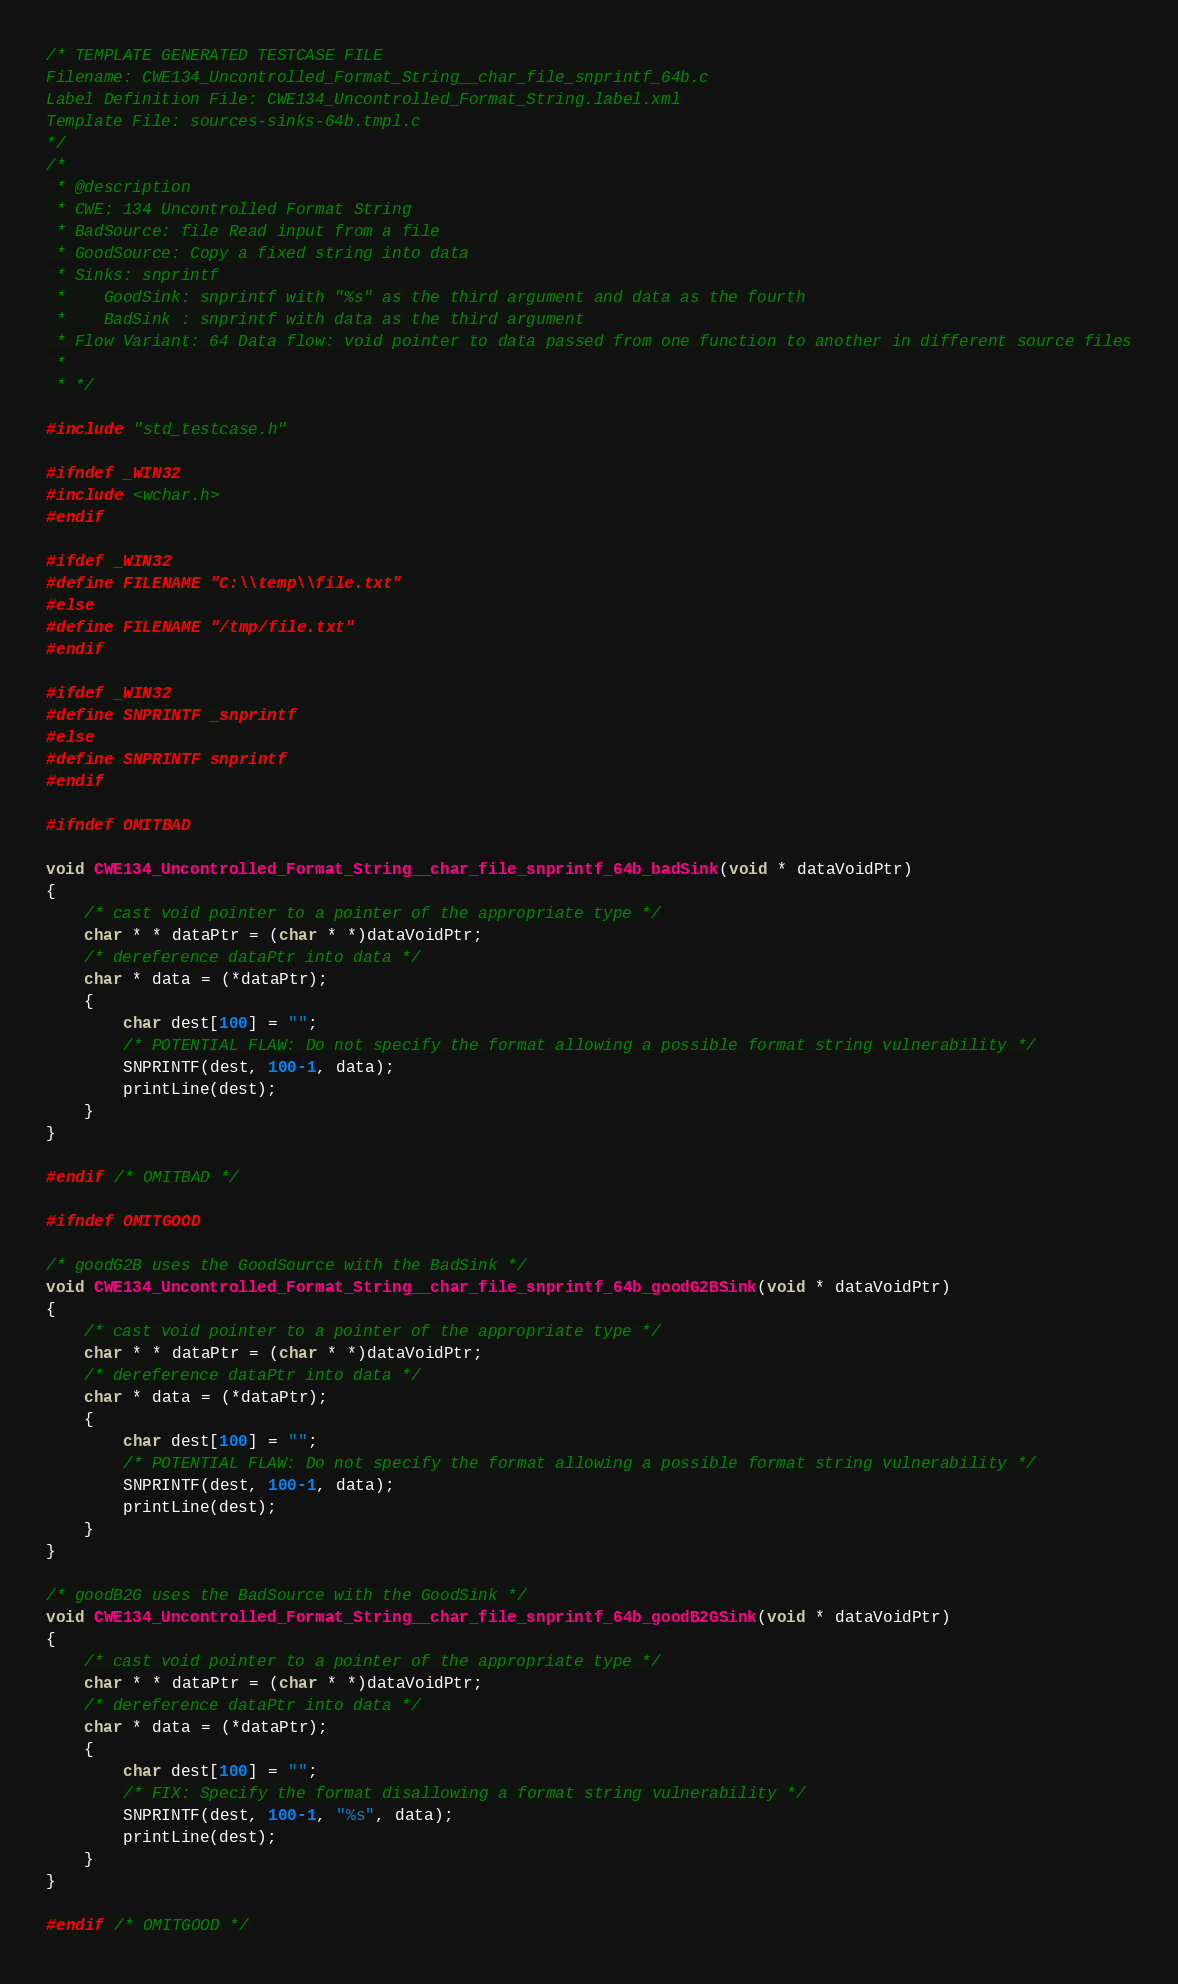<code> <loc_0><loc_0><loc_500><loc_500><_C_>/* TEMPLATE GENERATED TESTCASE FILE
Filename: CWE134_Uncontrolled_Format_String__char_file_snprintf_64b.c
Label Definition File: CWE134_Uncontrolled_Format_String.label.xml
Template File: sources-sinks-64b.tmpl.c
*/
/*
 * @description
 * CWE: 134 Uncontrolled Format String
 * BadSource: file Read input from a file
 * GoodSource: Copy a fixed string into data
 * Sinks: snprintf
 *    GoodSink: snprintf with "%s" as the third argument and data as the fourth
 *    BadSink : snprintf with data as the third argument
 * Flow Variant: 64 Data flow: void pointer to data passed from one function to another in different source files
 *
 * */

#include "std_testcase.h"

#ifndef _WIN32
#include <wchar.h>
#endif

#ifdef _WIN32
#define FILENAME "C:\\temp\\file.txt"
#else
#define FILENAME "/tmp/file.txt"
#endif

#ifdef _WIN32
#define SNPRINTF _snprintf
#else
#define SNPRINTF snprintf
#endif

#ifndef OMITBAD

void CWE134_Uncontrolled_Format_String__char_file_snprintf_64b_badSink(void * dataVoidPtr)
{
    /* cast void pointer to a pointer of the appropriate type */
    char * * dataPtr = (char * *)dataVoidPtr;
    /* dereference dataPtr into data */
    char * data = (*dataPtr);
    {
        char dest[100] = "";
        /* POTENTIAL FLAW: Do not specify the format allowing a possible format string vulnerability */
        SNPRINTF(dest, 100-1, data);
        printLine(dest);
    }
}

#endif /* OMITBAD */

#ifndef OMITGOOD

/* goodG2B uses the GoodSource with the BadSink */
void CWE134_Uncontrolled_Format_String__char_file_snprintf_64b_goodG2BSink(void * dataVoidPtr)
{
    /* cast void pointer to a pointer of the appropriate type */
    char * * dataPtr = (char * *)dataVoidPtr;
    /* dereference dataPtr into data */
    char * data = (*dataPtr);
    {
        char dest[100] = "";
        /* POTENTIAL FLAW: Do not specify the format allowing a possible format string vulnerability */
        SNPRINTF(dest, 100-1, data);
        printLine(dest);
    }
}

/* goodB2G uses the BadSource with the GoodSink */
void CWE134_Uncontrolled_Format_String__char_file_snprintf_64b_goodB2GSink(void * dataVoidPtr)
{
    /* cast void pointer to a pointer of the appropriate type */
    char * * dataPtr = (char * *)dataVoidPtr;
    /* dereference dataPtr into data */
    char * data = (*dataPtr);
    {
        char dest[100] = "";
        /* FIX: Specify the format disallowing a format string vulnerability */
        SNPRINTF(dest, 100-1, "%s", data);
        printLine(dest);
    }
}

#endif /* OMITGOOD */
</code> 